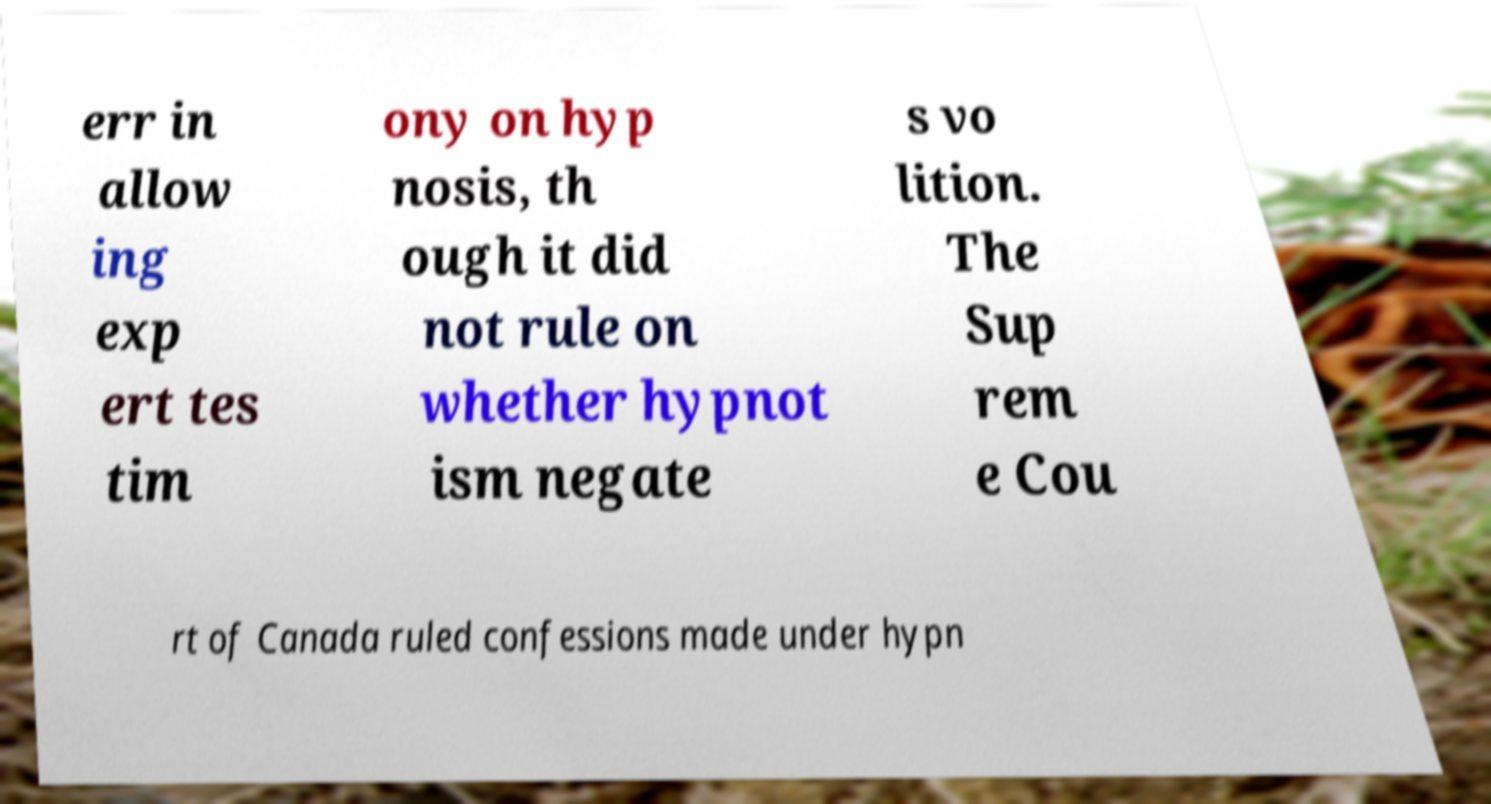Could you extract and type out the text from this image? err in allow ing exp ert tes tim ony on hyp nosis, th ough it did not rule on whether hypnot ism negate s vo lition. The Sup rem e Cou rt of Canada ruled confessions made under hypn 